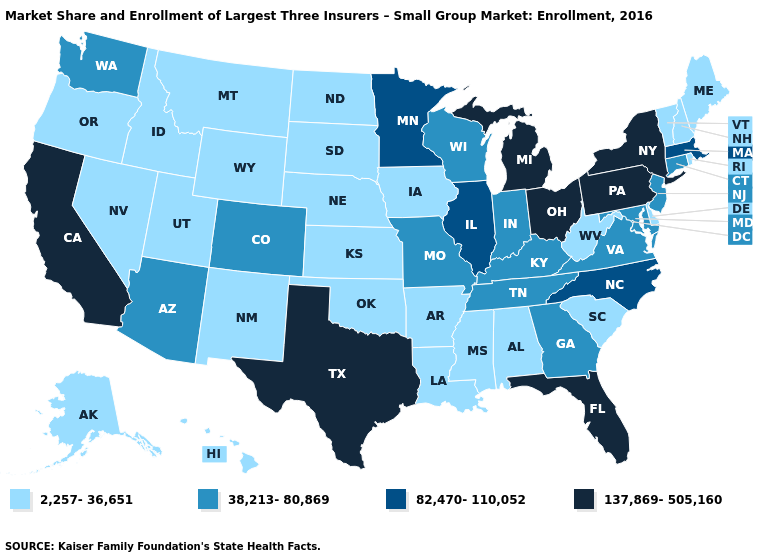Name the states that have a value in the range 82,470-110,052?
Be succinct. Illinois, Massachusetts, Minnesota, North Carolina. Which states hav the highest value in the West?
Answer briefly. California. Name the states that have a value in the range 82,470-110,052?
Quick response, please. Illinois, Massachusetts, Minnesota, North Carolina. Among the states that border Nevada , which have the highest value?
Be succinct. California. What is the value of Nevada?
Concise answer only. 2,257-36,651. What is the lowest value in the South?
Short answer required. 2,257-36,651. Name the states that have a value in the range 2,257-36,651?
Concise answer only. Alabama, Alaska, Arkansas, Delaware, Hawaii, Idaho, Iowa, Kansas, Louisiana, Maine, Mississippi, Montana, Nebraska, Nevada, New Hampshire, New Mexico, North Dakota, Oklahoma, Oregon, Rhode Island, South Carolina, South Dakota, Utah, Vermont, West Virginia, Wyoming. Does the first symbol in the legend represent the smallest category?
Concise answer only. Yes. What is the value of Washington?
Concise answer only. 38,213-80,869. Which states hav the highest value in the South?
Write a very short answer. Florida, Texas. What is the highest value in the South ?
Quick response, please. 137,869-505,160. What is the lowest value in states that border Louisiana?
Answer briefly. 2,257-36,651. Name the states that have a value in the range 2,257-36,651?
Keep it brief. Alabama, Alaska, Arkansas, Delaware, Hawaii, Idaho, Iowa, Kansas, Louisiana, Maine, Mississippi, Montana, Nebraska, Nevada, New Hampshire, New Mexico, North Dakota, Oklahoma, Oregon, Rhode Island, South Carolina, South Dakota, Utah, Vermont, West Virginia, Wyoming. Does Pennsylvania have a lower value than Minnesota?
Short answer required. No. Which states hav the highest value in the MidWest?
Answer briefly. Michigan, Ohio. 